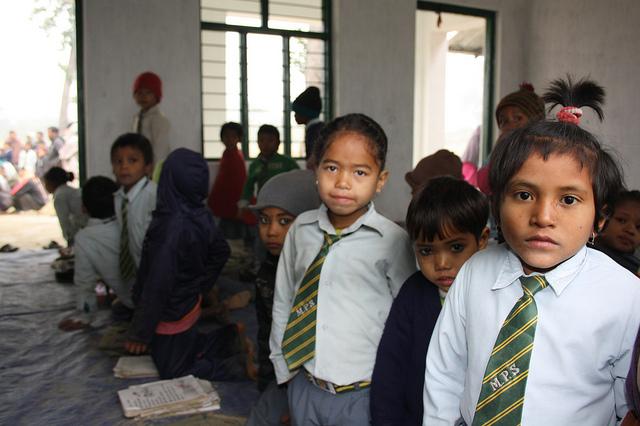How many kids wearing a tie?
Give a very brief answer. 3. What color are their shirts?
Be succinct. White. Are these businessmen?
Keep it brief. No. Does anyone have a tattoo on their neck?
Answer briefly. No. How many pieces of jewelry are in the photo?
Short answer required. 0. What color tie is the boy on the right wearing?
Short answer required. Green and yellow. How many men are wearing ties?
Be succinct. 3. What are the letters on the child's tie?
Answer briefly. Mps. 